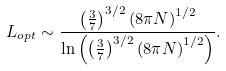Convert formula to latex. <formula><loc_0><loc_0><loc_500><loc_500>L _ { o p t } \sim \frac { \left ( \frac { 3 } { 7 } \right ) ^ { 3 / 2 } \left ( 8 \pi N \right ) ^ { 1 / 2 } } { \ln \left ( \left ( \frac { 3 } { 7 } \right ) ^ { 3 / 2 } \left ( 8 \pi N \right ) ^ { 1 / 2 } \right ) } .</formula> 